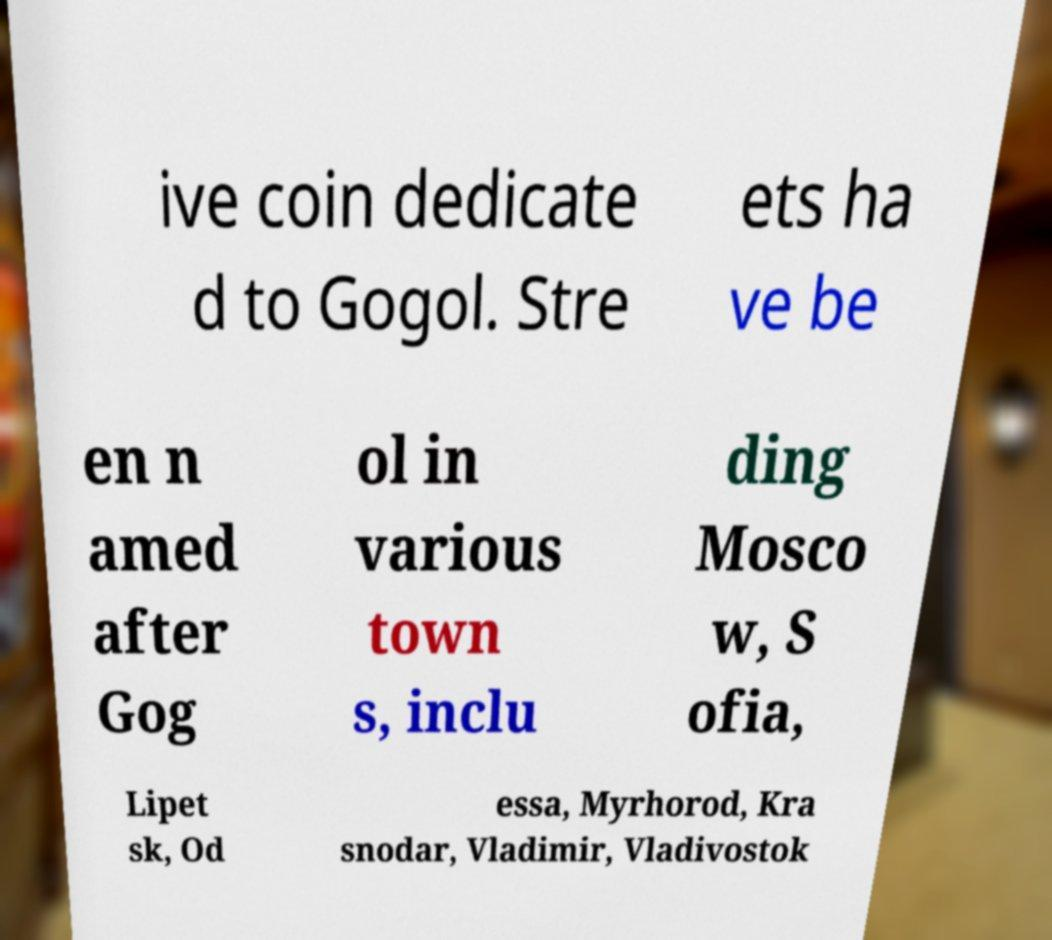Please read and relay the text visible in this image. What does it say? ive coin dedicate d to Gogol. Stre ets ha ve be en n amed after Gog ol in various town s, inclu ding Mosco w, S ofia, Lipet sk, Od essa, Myrhorod, Kra snodar, Vladimir, Vladivostok 